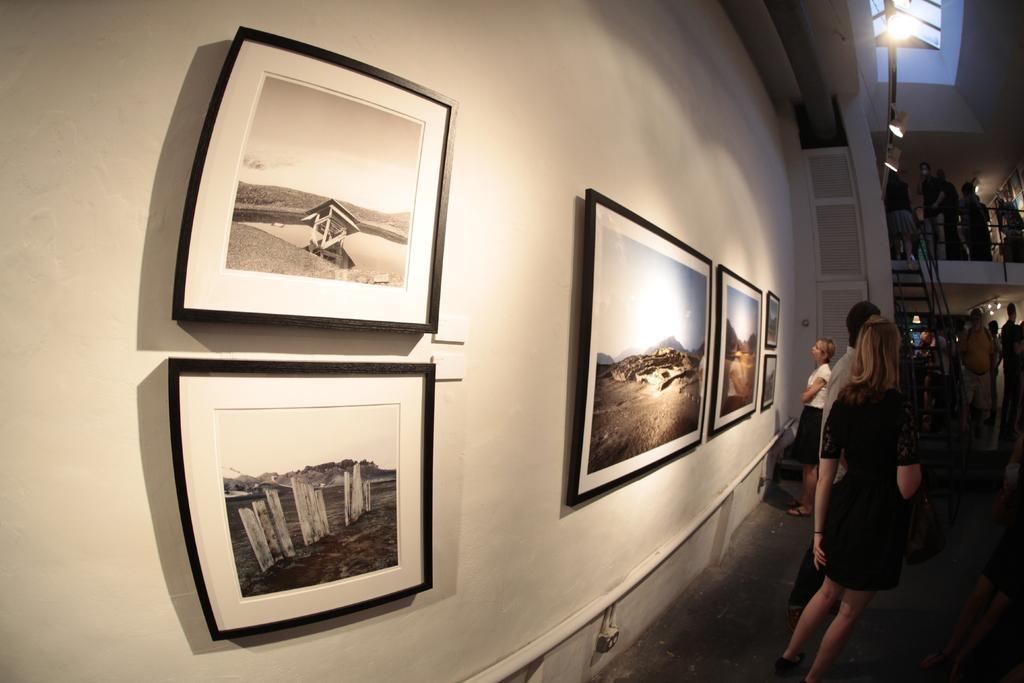How would you summarize this image in a sentence or two? In the foreground of this image, there are few frames on the wall. On the right, there are few people standing on the floor and also we can see stairs, railing, lights to the ceiling and few people standing near it. 